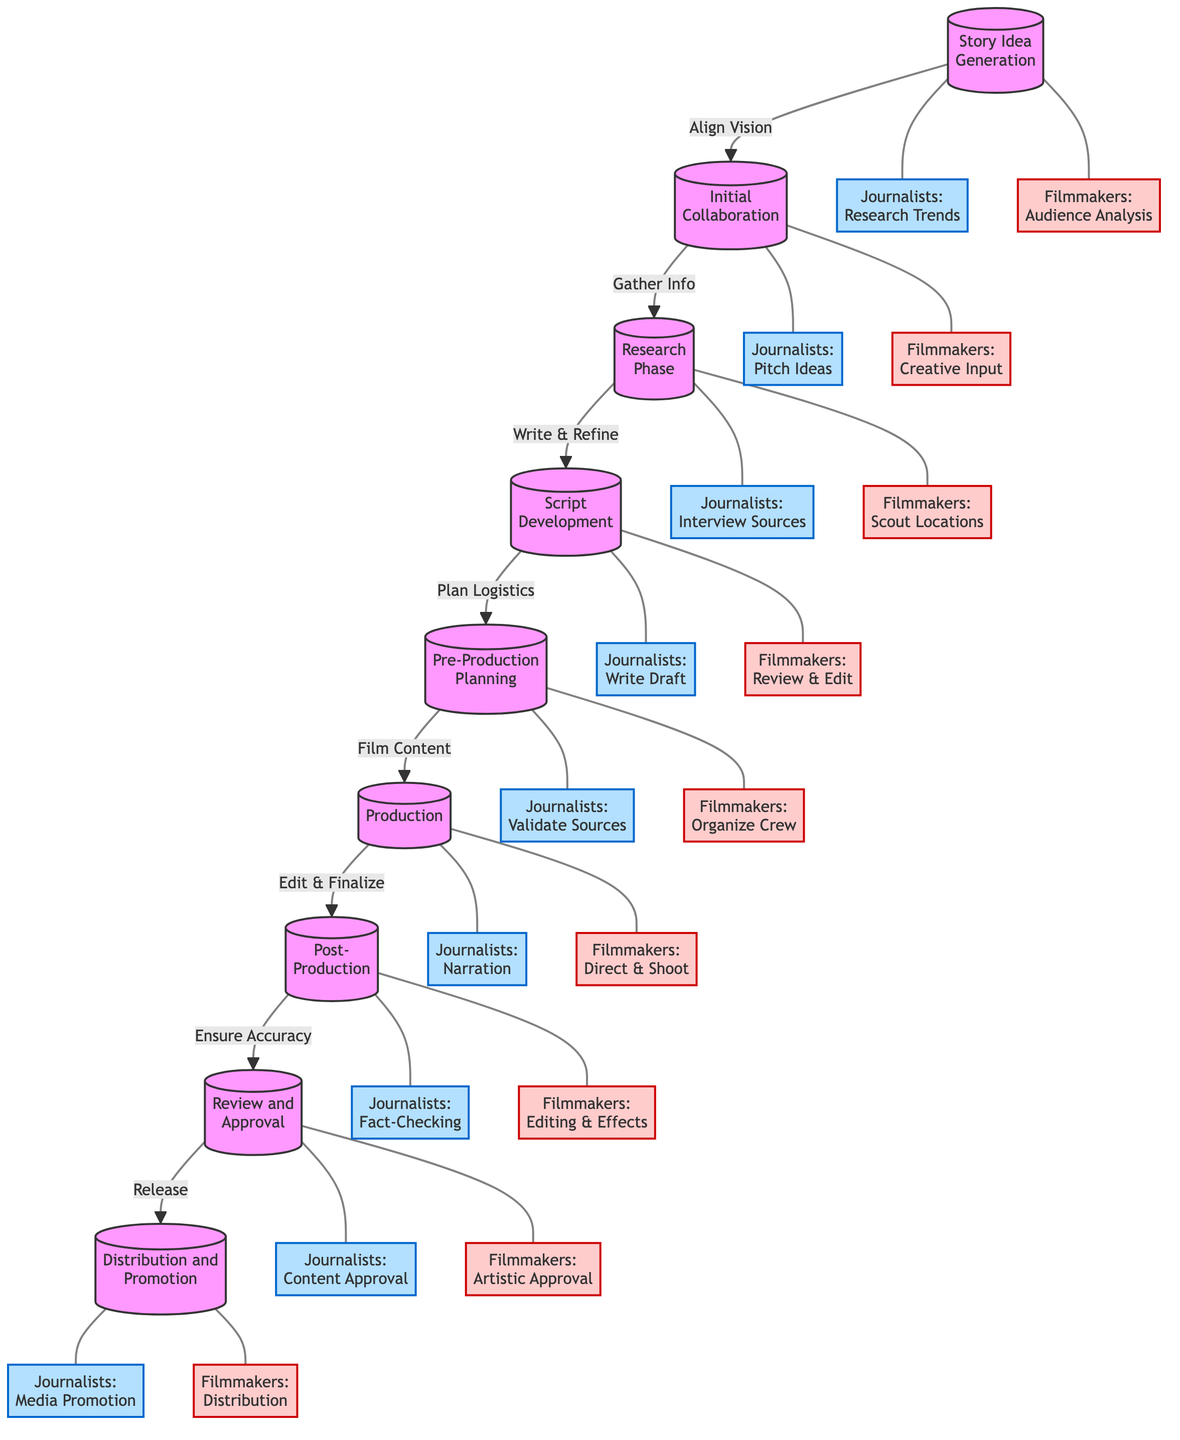What is the first step in the collaborative workflow? The diagram indicates that the first step is "Story Idea Generation," where journalists research trends and filmmakers conduct audience analysis.
Answer: Story Idea Generation How many main stages are there in the workflow? The diagram displays a total of nine main stages that detail the collaborative workflow between journalists and filmmakers.
Answer: Nine What do journalists do during the Research Phase? According to the diagram, during the Research Phase, journalists interview sources. This step is highlighted as part of the actions that journalists take in that stage.
Answer: Interview Sources What is the action taken by filmmakers in the Script Development stage? The diagram states that in the Script Development stage, filmmakers review and edit the script collaboratively, which is a key action in that phase.
Answer: Review and Edit What is the final step in the workflow? As per the flowchart, the final step of the workflow is "Distribution and Promotion," which involves releasing and promoting the film.
Answer: Distribution and Promotion Which stage comes after Initial Collaboration? The flowchart clearly indicates that "Research Phase" follows the "Initial Collaboration" stage, establishing the sequence of the workflow.
Answer: Research Phase In the Post-Production phase, what do journalists focus on? The diagram specifies that in the Post-Production phase, journalists are responsible for fact-checking the content, ensuring it aligns with their journalistic standards.
Answer: Fact-Checking How do journalists and filmmakers interact at the Pre-Production Planning stage? The diagram demonstrates that during the Pre-Production Planning stage, journalists validate sources while filmmakers organize the crew, establishing collaborative action.
Answer: Validate Sources and Organize Crew What connects the Research Phase to Script Development? The flowchart shows a direct link labeled "Write & Refine" that transitions from the Research Phase to the Script Development stage, indicating the workflow connection.
Answer: Write & Refine 